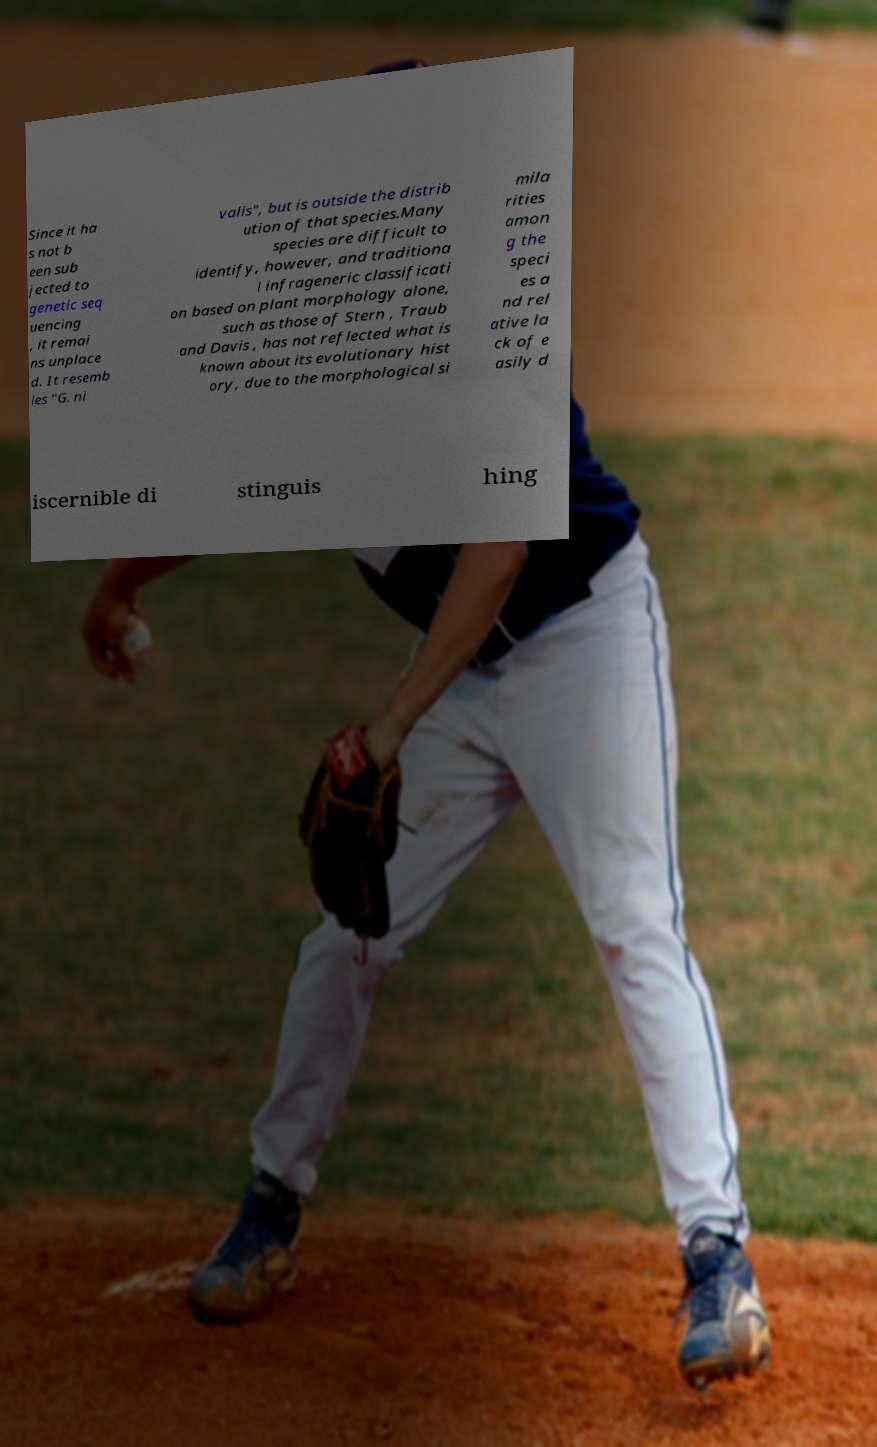There's text embedded in this image that I need extracted. Can you transcribe it verbatim? Since it ha s not b een sub jected to genetic seq uencing , it remai ns unplace d. It resemb les "G. ni valis", but is outside the distrib ution of that species.Many species are difficult to identify, however, and traditiona l infrageneric classificati on based on plant morphology alone, such as those of Stern , Traub and Davis , has not reflected what is known about its evolutionary hist ory, due to the morphological si mila rities amon g the speci es a nd rel ative la ck of e asily d iscernible di stinguis hing 